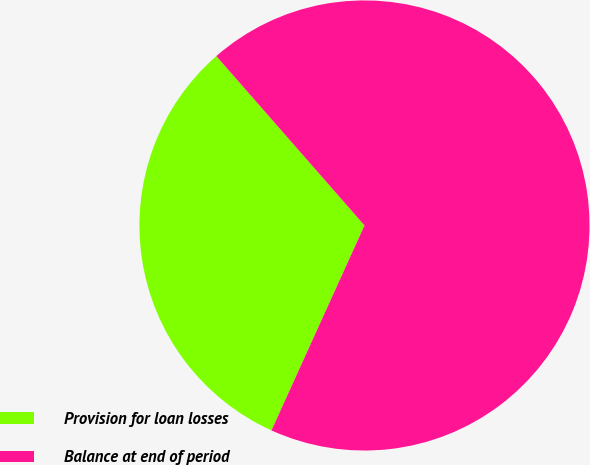Convert chart to OTSL. <chart><loc_0><loc_0><loc_500><loc_500><pie_chart><fcel>Provision for loan losses<fcel>Balance at end of period<nl><fcel>31.78%<fcel>68.22%<nl></chart> 